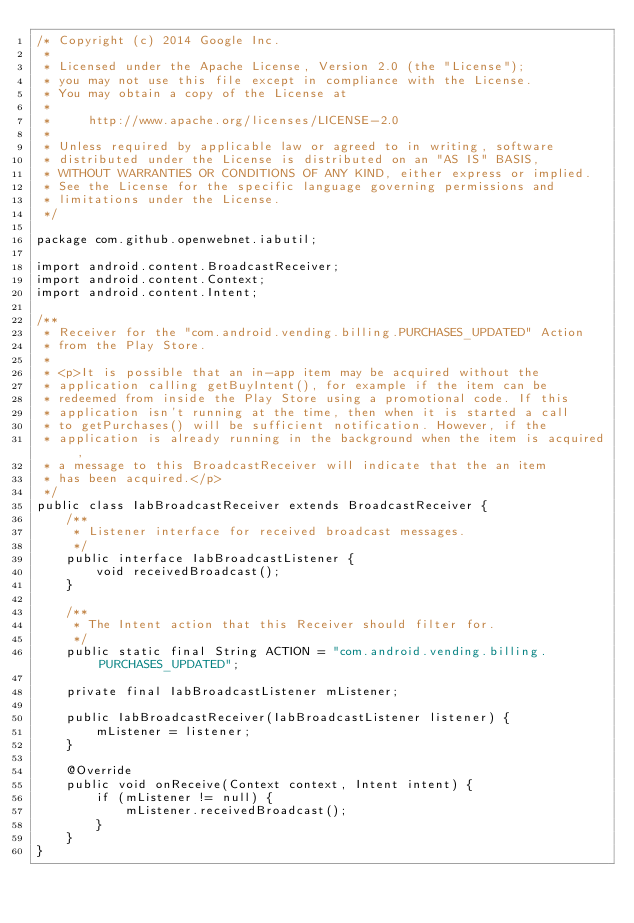<code> <loc_0><loc_0><loc_500><loc_500><_Java_>/* Copyright (c) 2014 Google Inc.
 *
 * Licensed under the Apache License, Version 2.0 (the "License");
 * you may not use this file except in compliance with the License.
 * You may obtain a copy of the License at
 *
 *     http://www.apache.org/licenses/LICENSE-2.0
 *
 * Unless required by applicable law or agreed to in writing, software
 * distributed under the License is distributed on an "AS IS" BASIS,
 * WITHOUT WARRANTIES OR CONDITIONS OF ANY KIND, either express or implied.
 * See the License for the specific language governing permissions and
 * limitations under the License.
 */

package com.github.openwebnet.iabutil;

import android.content.BroadcastReceiver;
import android.content.Context;
import android.content.Intent;

/**
 * Receiver for the "com.android.vending.billing.PURCHASES_UPDATED" Action
 * from the Play Store.
 *
 * <p>It is possible that an in-app item may be acquired without the
 * application calling getBuyIntent(), for example if the item can be
 * redeemed from inside the Play Store using a promotional code. If this
 * application isn't running at the time, then when it is started a call
 * to getPurchases() will be sufficient notification. However, if the
 * application is already running in the background when the item is acquired,
 * a message to this BroadcastReceiver will indicate that the an item
 * has been acquired.</p>
 */
public class IabBroadcastReceiver extends BroadcastReceiver {
    /**
     * Listener interface for received broadcast messages.
     */
    public interface IabBroadcastListener {
        void receivedBroadcast();
    }

    /**
     * The Intent action that this Receiver should filter for.
     */
    public static final String ACTION = "com.android.vending.billing.PURCHASES_UPDATED";

    private final IabBroadcastListener mListener;

    public IabBroadcastReceiver(IabBroadcastListener listener) {
        mListener = listener;
    }

    @Override
    public void onReceive(Context context, Intent intent) {
        if (mListener != null) {
            mListener.receivedBroadcast();
        }
    }
}
</code> 